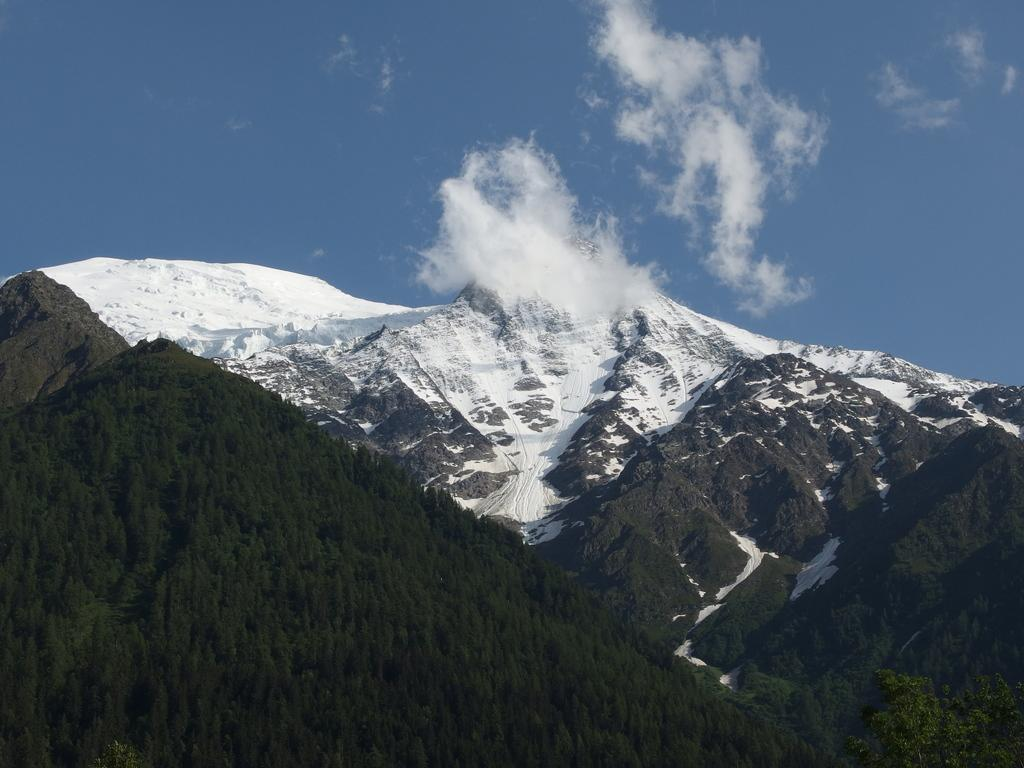What type of vegetation can be seen in the image? There are trees in the image. What geographical feature is present in the image? There is a mountain in the image. What weather condition is depicted in the image? There is snow in the image. What is visible in the sky in the image? The sky is visible in the image, and clouds are present. What type of basin is used for digestion in the image? There is no basin or reference to digestion present in the image. How does the coach help the trees grow in the image? There is no coach present in the image, and trees grow through natural processes, not through the assistance of a coach. 